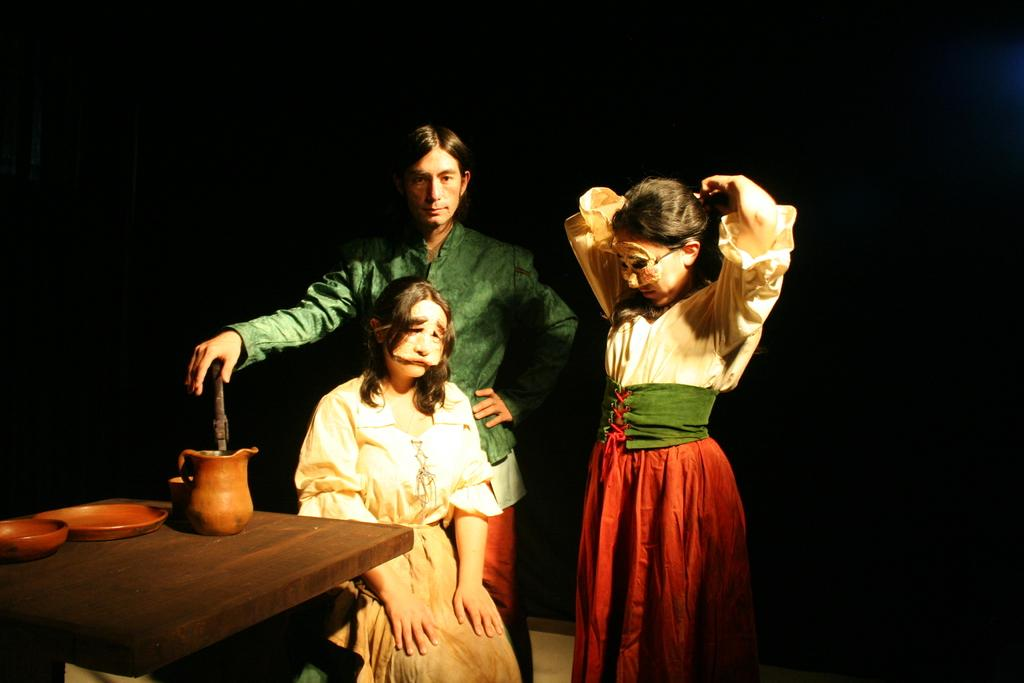What is the woman in the image doing? The woman is sitting on a chair in the image. Are there any other people in the image? Yes, there are two people standing behind the woman. What can be seen on the table in the image? There is a jar and two plates on the table in the image. Can you describe the table in the image? The table is a piece of furniture where the jar and plates are placed. What type of alarm is ringing in the image? There is no alarm present in the image. Can you describe the bubble that is floating in the image? There is no bubble present in the image. 